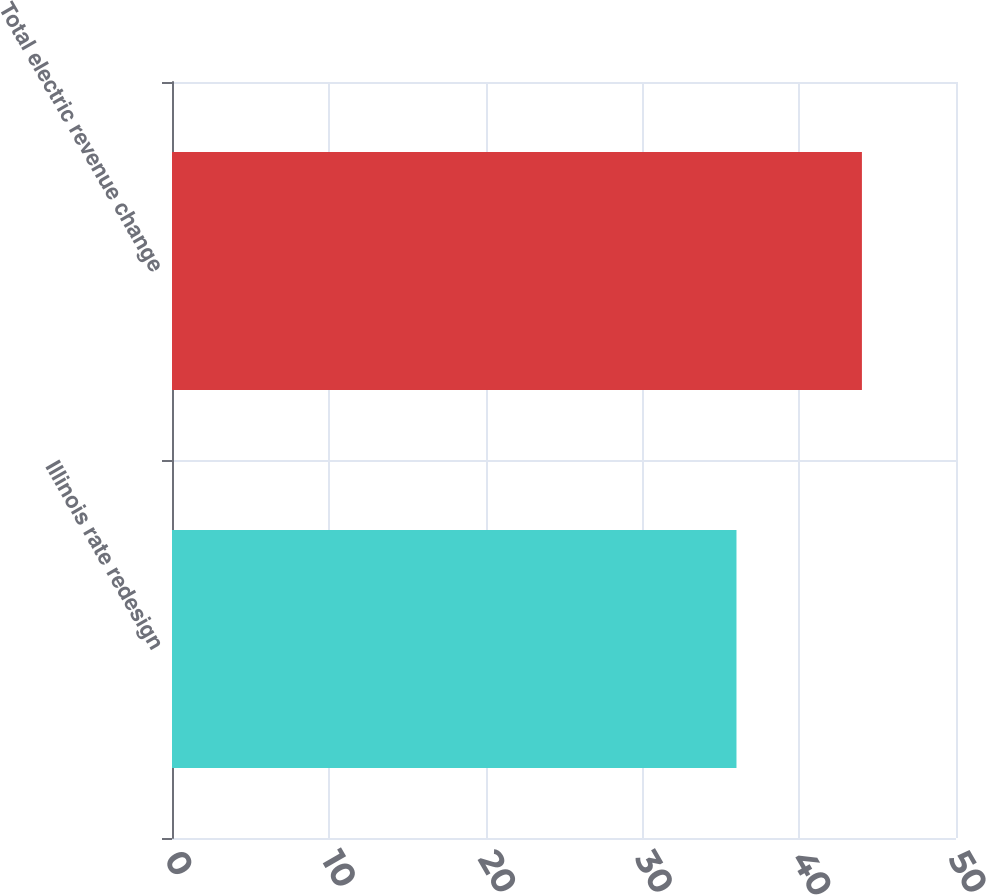<chart> <loc_0><loc_0><loc_500><loc_500><bar_chart><fcel>Illinois rate redesign<fcel>Total electric revenue change<nl><fcel>36<fcel>44<nl></chart> 